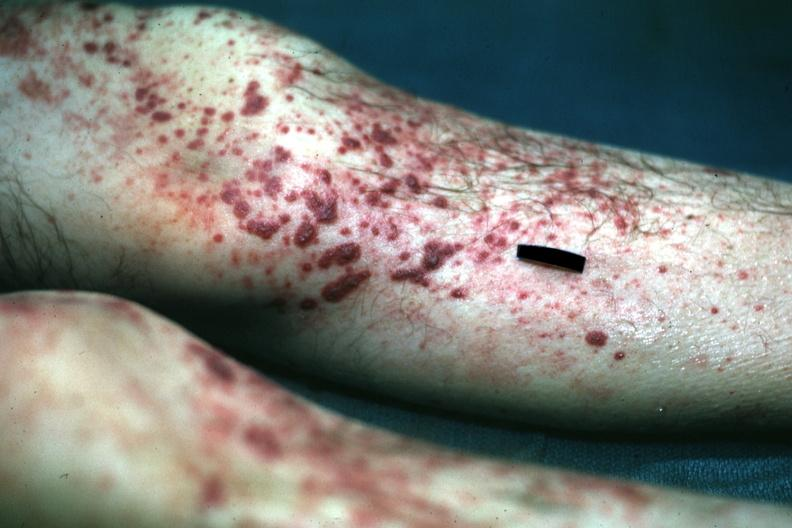where is this?
Answer the question using a single word or phrase. Skin 